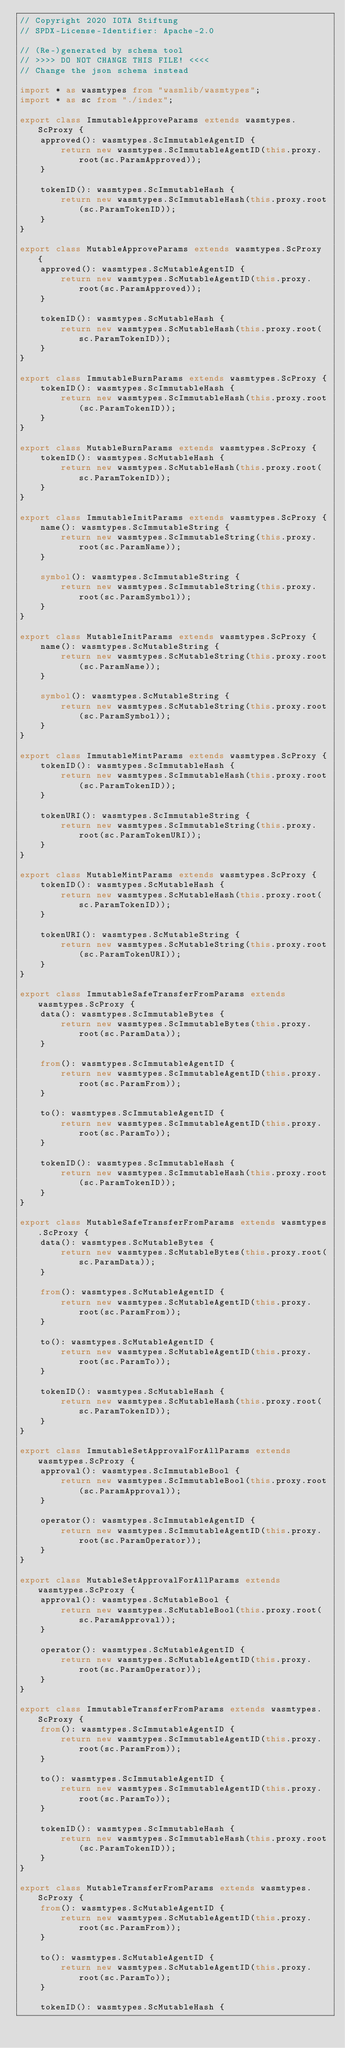Convert code to text. <code><loc_0><loc_0><loc_500><loc_500><_TypeScript_>// Copyright 2020 IOTA Stiftung
// SPDX-License-Identifier: Apache-2.0

// (Re-)generated by schema tool
// >>>> DO NOT CHANGE THIS FILE! <<<<
// Change the json schema instead

import * as wasmtypes from "wasmlib/wasmtypes";
import * as sc from "./index";

export class ImmutableApproveParams extends wasmtypes.ScProxy {
	approved(): wasmtypes.ScImmutableAgentID {
		return new wasmtypes.ScImmutableAgentID(this.proxy.root(sc.ParamApproved));
	}

	tokenID(): wasmtypes.ScImmutableHash {
		return new wasmtypes.ScImmutableHash(this.proxy.root(sc.ParamTokenID));
	}
}

export class MutableApproveParams extends wasmtypes.ScProxy {
	approved(): wasmtypes.ScMutableAgentID {
		return new wasmtypes.ScMutableAgentID(this.proxy.root(sc.ParamApproved));
	}

	tokenID(): wasmtypes.ScMutableHash {
		return new wasmtypes.ScMutableHash(this.proxy.root(sc.ParamTokenID));
	}
}

export class ImmutableBurnParams extends wasmtypes.ScProxy {
	tokenID(): wasmtypes.ScImmutableHash {
		return new wasmtypes.ScImmutableHash(this.proxy.root(sc.ParamTokenID));
	}
}

export class MutableBurnParams extends wasmtypes.ScProxy {
	tokenID(): wasmtypes.ScMutableHash {
		return new wasmtypes.ScMutableHash(this.proxy.root(sc.ParamTokenID));
	}
}

export class ImmutableInitParams extends wasmtypes.ScProxy {
	name(): wasmtypes.ScImmutableString {
		return new wasmtypes.ScImmutableString(this.proxy.root(sc.ParamName));
	}

	symbol(): wasmtypes.ScImmutableString {
		return new wasmtypes.ScImmutableString(this.proxy.root(sc.ParamSymbol));
	}
}

export class MutableInitParams extends wasmtypes.ScProxy {
	name(): wasmtypes.ScMutableString {
		return new wasmtypes.ScMutableString(this.proxy.root(sc.ParamName));
	}

	symbol(): wasmtypes.ScMutableString {
		return new wasmtypes.ScMutableString(this.proxy.root(sc.ParamSymbol));
	}
}

export class ImmutableMintParams extends wasmtypes.ScProxy {
	tokenID(): wasmtypes.ScImmutableHash {
		return new wasmtypes.ScImmutableHash(this.proxy.root(sc.ParamTokenID));
	}

	tokenURI(): wasmtypes.ScImmutableString {
		return new wasmtypes.ScImmutableString(this.proxy.root(sc.ParamTokenURI));
	}
}

export class MutableMintParams extends wasmtypes.ScProxy {
	tokenID(): wasmtypes.ScMutableHash {
		return new wasmtypes.ScMutableHash(this.proxy.root(sc.ParamTokenID));
	}

	tokenURI(): wasmtypes.ScMutableString {
		return new wasmtypes.ScMutableString(this.proxy.root(sc.ParamTokenURI));
	}
}

export class ImmutableSafeTransferFromParams extends wasmtypes.ScProxy {
	data(): wasmtypes.ScImmutableBytes {
		return new wasmtypes.ScImmutableBytes(this.proxy.root(sc.ParamData));
	}

	from(): wasmtypes.ScImmutableAgentID {
		return new wasmtypes.ScImmutableAgentID(this.proxy.root(sc.ParamFrom));
	}

	to(): wasmtypes.ScImmutableAgentID {
		return new wasmtypes.ScImmutableAgentID(this.proxy.root(sc.ParamTo));
	}

	tokenID(): wasmtypes.ScImmutableHash {
		return new wasmtypes.ScImmutableHash(this.proxy.root(sc.ParamTokenID));
	}
}

export class MutableSafeTransferFromParams extends wasmtypes.ScProxy {
	data(): wasmtypes.ScMutableBytes {
		return new wasmtypes.ScMutableBytes(this.proxy.root(sc.ParamData));
	}

	from(): wasmtypes.ScMutableAgentID {
		return new wasmtypes.ScMutableAgentID(this.proxy.root(sc.ParamFrom));
	}

	to(): wasmtypes.ScMutableAgentID {
		return new wasmtypes.ScMutableAgentID(this.proxy.root(sc.ParamTo));
	}

	tokenID(): wasmtypes.ScMutableHash {
		return new wasmtypes.ScMutableHash(this.proxy.root(sc.ParamTokenID));
	}
}

export class ImmutableSetApprovalForAllParams extends wasmtypes.ScProxy {
	approval(): wasmtypes.ScImmutableBool {
		return new wasmtypes.ScImmutableBool(this.proxy.root(sc.ParamApproval));
	}

	operator(): wasmtypes.ScImmutableAgentID {
		return new wasmtypes.ScImmutableAgentID(this.proxy.root(sc.ParamOperator));
	}
}

export class MutableSetApprovalForAllParams extends wasmtypes.ScProxy {
	approval(): wasmtypes.ScMutableBool {
		return new wasmtypes.ScMutableBool(this.proxy.root(sc.ParamApproval));
	}

	operator(): wasmtypes.ScMutableAgentID {
		return new wasmtypes.ScMutableAgentID(this.proxy.root(sc.ParamOperator));
	}
}

export class ImmutableTransferFromParams extends wasmtypes.ScProxy {
	from(): wasmtypes.ScImmutableAgentID {
		return new wasmtypes.ScImmutableAgentID(this.proxy.root(sc.ParamFrom));
	}

	to(): wasmtypes.ScImmutableAgentID {
		return new wasmtypes.ScImmutableAgentID(this.proxy.root(sc.ParamTo));
	}

	tokenID(): wasmtypes.ScImmutableHash {
		return new wasmtypes.ScImmutableHash(this.proxy.root(sc.ParamTokenID));
	}
}

export class MutableTransferFromParams extends wasmtypes.ScProxy {
	from(): wasmtypes.ScMutableAgentID {
		return new wasmtypes.ScMutableAgentID(this.proxy.root(sc.ParamFrom));
	}

	to(): wasmtypes.ScMutableAgentID {
		return new wasmtypes.ScMutableAgentID(this.proxy.root(sc.ParamTo));
	}

	tokenID(): wasmtypes.ScMutableHash {</code> 